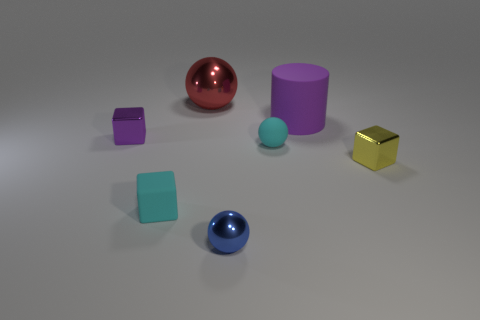Add 1 yellow objects. How many objects exist? 8 Subtract all balls. How many objects are left? 4 Subtract 1 red balls. How many objects are left? 6 Subtract all tiny yellow shiny cubes. Subtract all metal spheres. How many objects are left? 4 Add 3 big rubber cylinders. How many big rubber cylinders are left? 4 Add 7 purple matte things. How many purple matte things exist? 8 